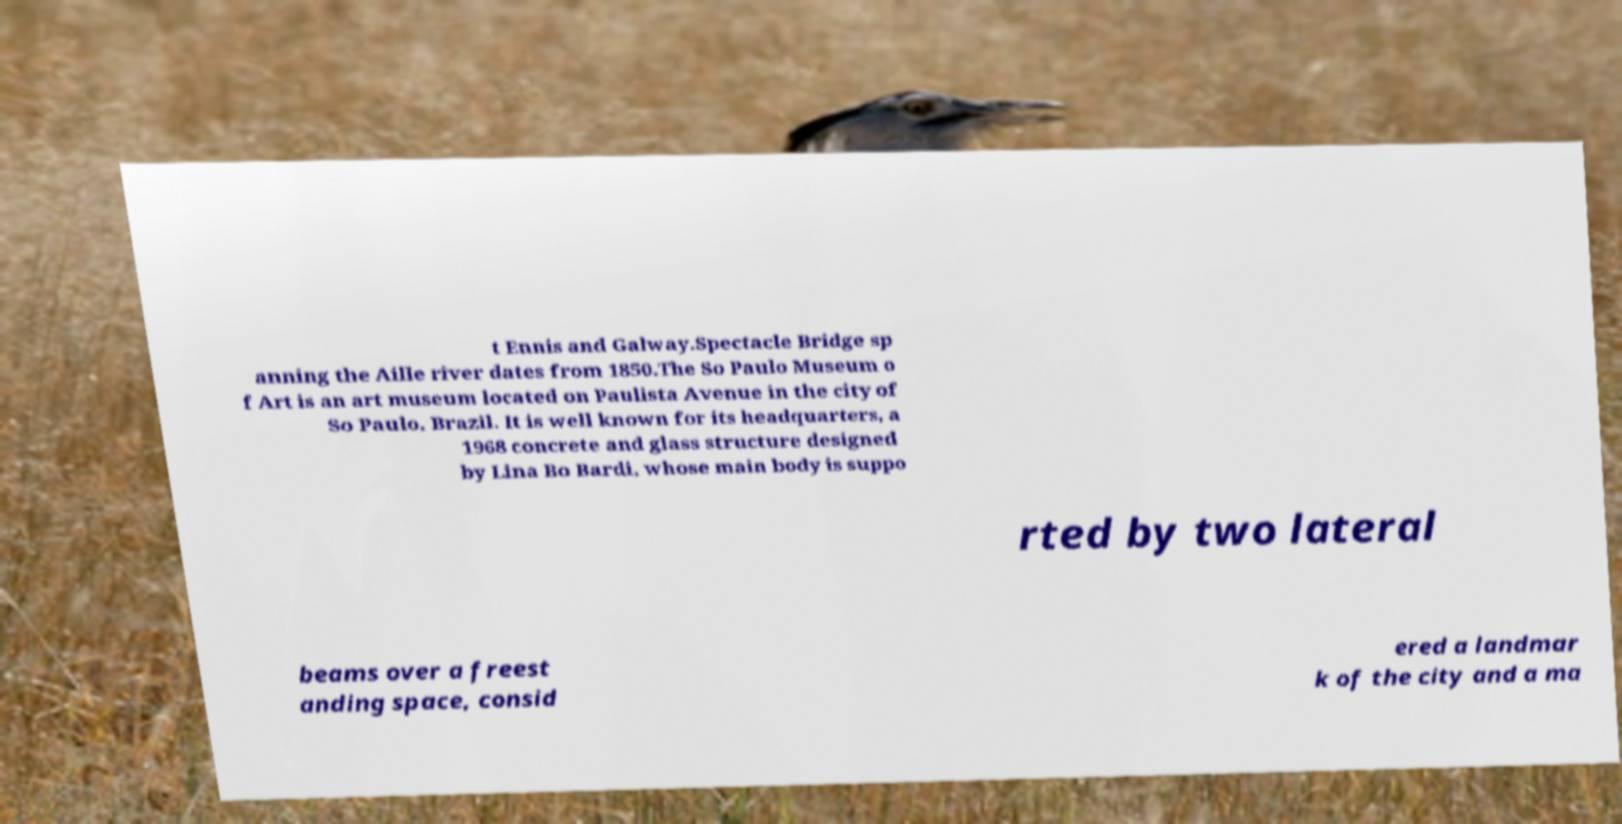Please identify and transcribe the text found in this image. t Ennis and Galway.Spectacle Bridge sp anning the Aille river dates from 1850.The So Paulo Museum o f Art is an art museum located on Paulista Avenue in the city of So Paulo, Brazil. It is well known for its headquarters, a 1968 concrete and glass structure designed by Lina Bo Bardi, whose main body is suppo rted by two lateral beams over a freest anding space, consid ered a landmar k of the city and a ma 